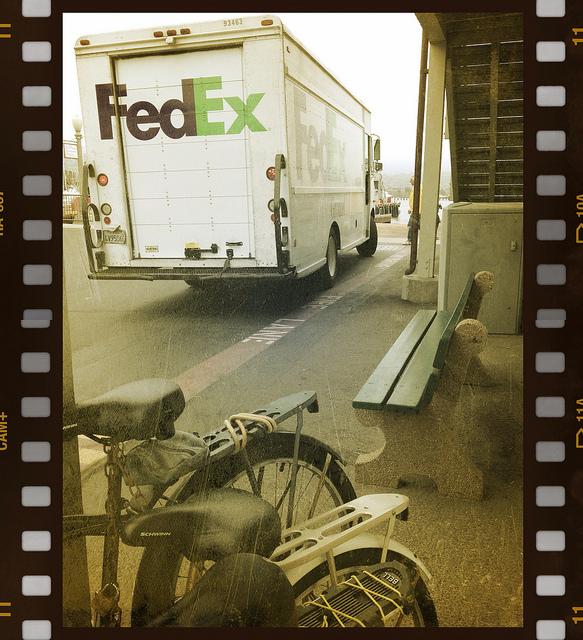How many wheels do you see?
Keep it brief. 4. What era was this taken in?
Give a very brief answer. Modern. Are there any people in the scene?
Quick response, please. No. What is the word on the door?
Keep it brief. Fedex. Do you see a ramp?
Answer briefly. No. What is the business' name written on the back of the truck?
Write a very short answer. Fedex. 